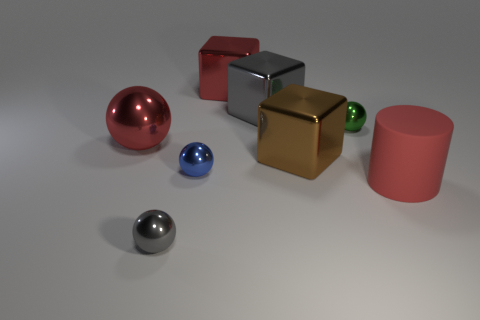Subtract all tiny green balls. How many balls are left? 3 Add 1 gray metal spheres. How many objects exist? 9 Subtract all brown cubes. How many cubes are left? 2 Subtract all cubes. How many objects are left? 5 Subtract 1 cubes. How many cubes are left? 2 Add 3 tiny green balls. How many tiny green balls exist? 4 Subtract 1 blue balls. How many objects are left? 7 Subtract all gray balls. Subtract all blue blocks. How many balls are left? 3 Subtract all tiny blue metallic objects. Subtract all green objects. How many objects are left? 6 Add 3 large cylinders. How many large cylinders are left? 4 